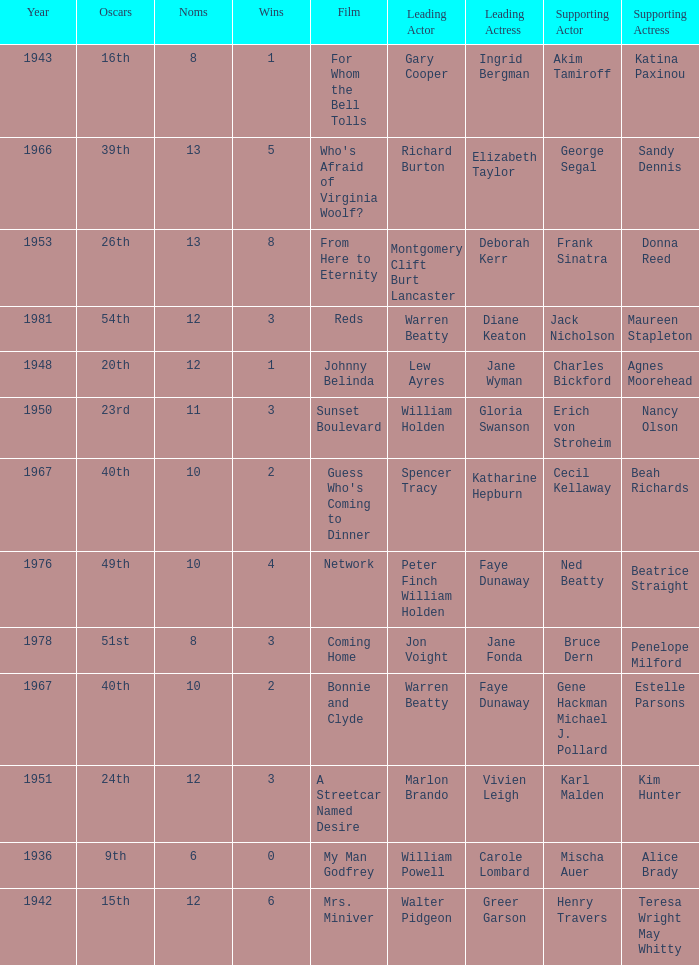Who was the leading actor in the film with a supporting actor named Cecil Kellaway? Spencer Tracy. 